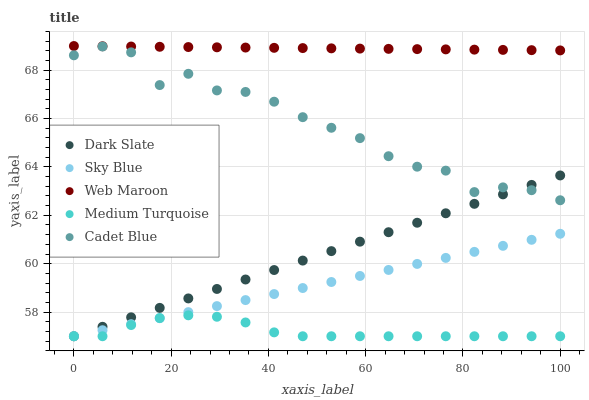Does Medium Turquoise have the minimum area under the curve?
Answer yes or no. Yes. Does Web Maroon have the maximum area under the curve?
Answer yes or no. Yes. Does Cadet Blue have the minimum area under the curve?
Answer yes or no. No. Does Cadet Blue have the maximum area under the curve?
Answer yes or no. No. Is Dark Slate the smoothest?
Answer yes or no. Yes. Is Cadet Blue the roughest?
Answer yes or no. Yes. Is Web Maroon the smoothest?
Answer yes or no. No. Is Web Maroon the roughest?
Answer yes or no. No. Does Dark Slate have the lowest value?
Answer yes or no. Yes. Does Cadet Blue have the lowest value?
Answer yes or no. No. Does Web Maroon have the highest value?
Answer yes or no. Yes. Does Cadet Blue have the highest value?
Answer yes or no. No. Is Cadet Blue less than Web Maroon?
Answer yes or no. Yes. Is Web Maroon greater than Sky Blue?
Answer yes or no. Yes. Does Medium Turquoise intersect Dark Slate?
Answer yes or no. Yes. Is Medium Turquoise less than Dark Slate?
Answer yes or no. No. Is Medium Turquoise greater than Dark Slate?
Answer yes or no. No. Does Cadet Blue intersect Web Maroon?
Answer yes or no. No. 